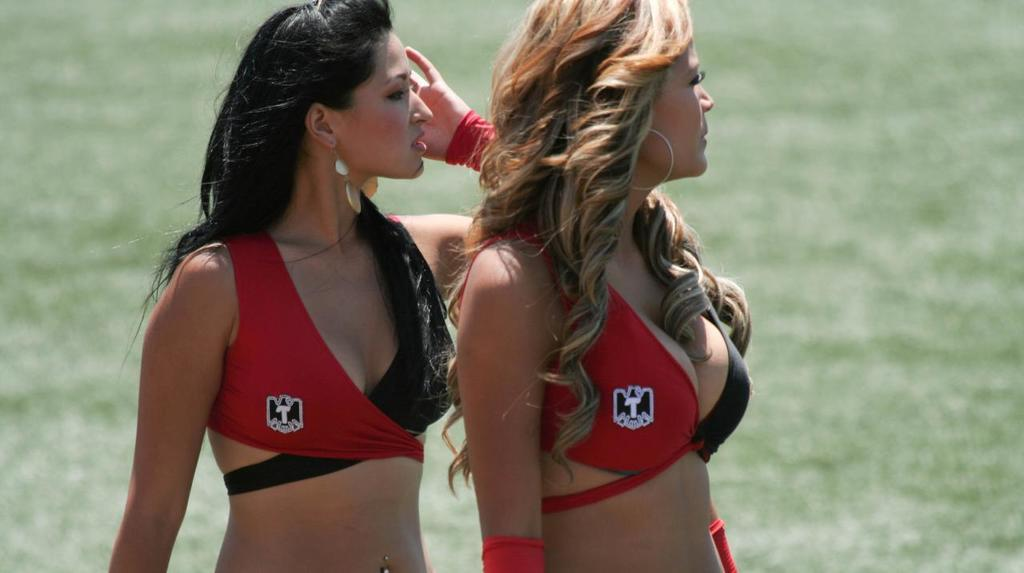<image>
Relay a brief, clear account of the picture shown. Two woman are wearing matching bikini tops that have a T on them. 